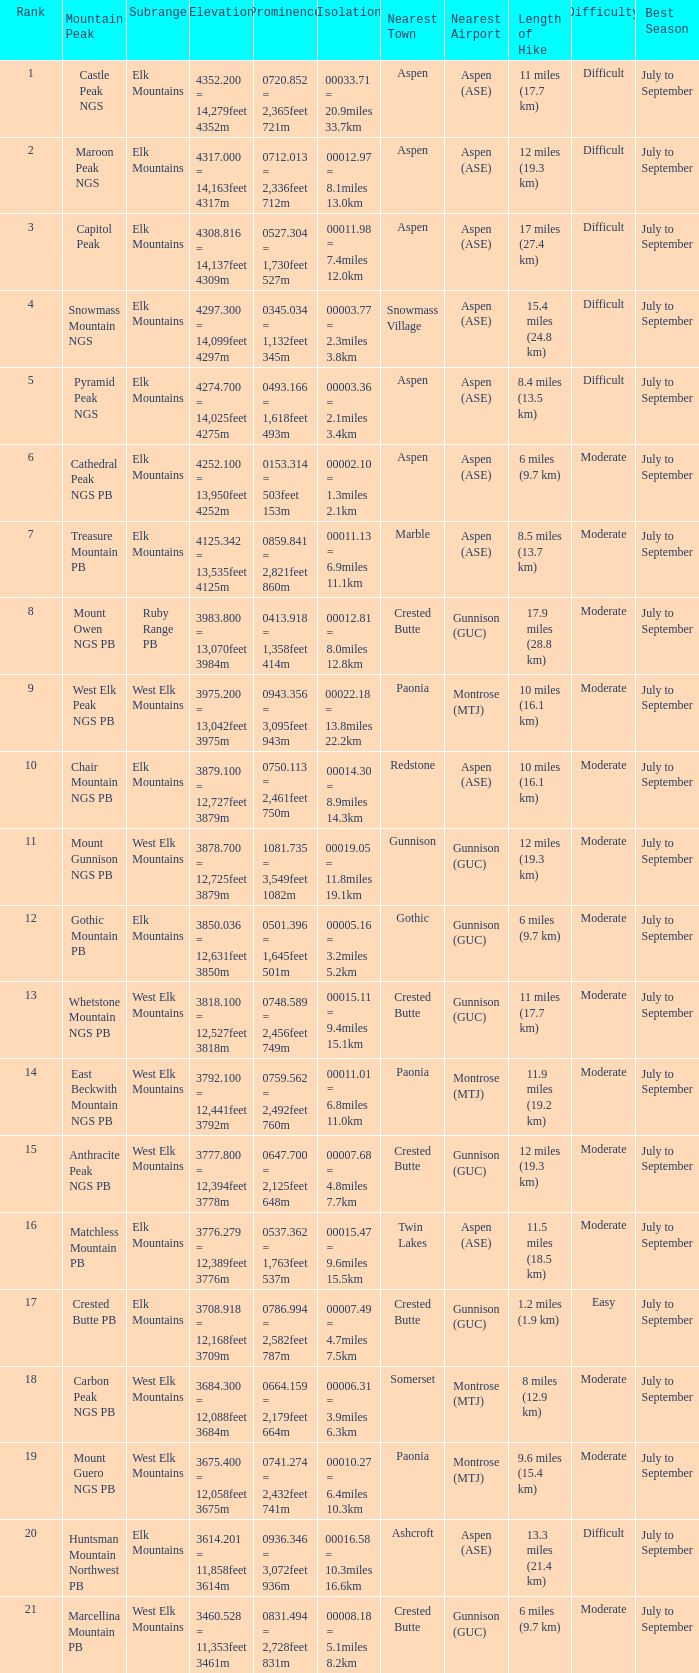Name the Rank of Rank Mountain Peak of crested butte pb? 17.0. 